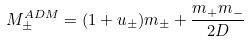Convert formula to latex. <formula><loc_0><loc_0><loc_500><loc_500>M ^ { A D M } _ { \pm } = ( 1 + u _ { \pm } ) m _ { \pm } + \frac { m _ { + } m _ { - } } { 2 D }</formula> 